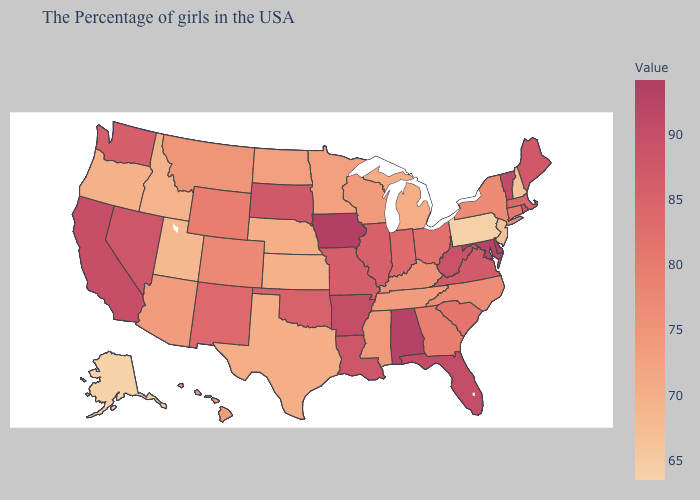Does Texas have a higher value than New Jersey?
Answer briefly. Yes. Does Iowa have the highest value in the MidWest?
Quick response, please. Yes. Does the map have missing data?
Concise answer only. No. Which states hav the highest value in the MidWest?
Short answer required. Iowa. Among the states that border Kansas , does Nebraska have the lowest value?
Answer briefly. Yes. Does Montana have the highest value in the USA?
Write a very short answer. No. Which states have the lowest value in the USA?
Concise answer only. Alaska. 